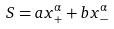Convert formula to latex. <formula><loc_0><loc_0><loc_500><loc_500>S = a x _ { + } ^ { \alpha } + b x _ { - } ^ { \alpha }</formula> 